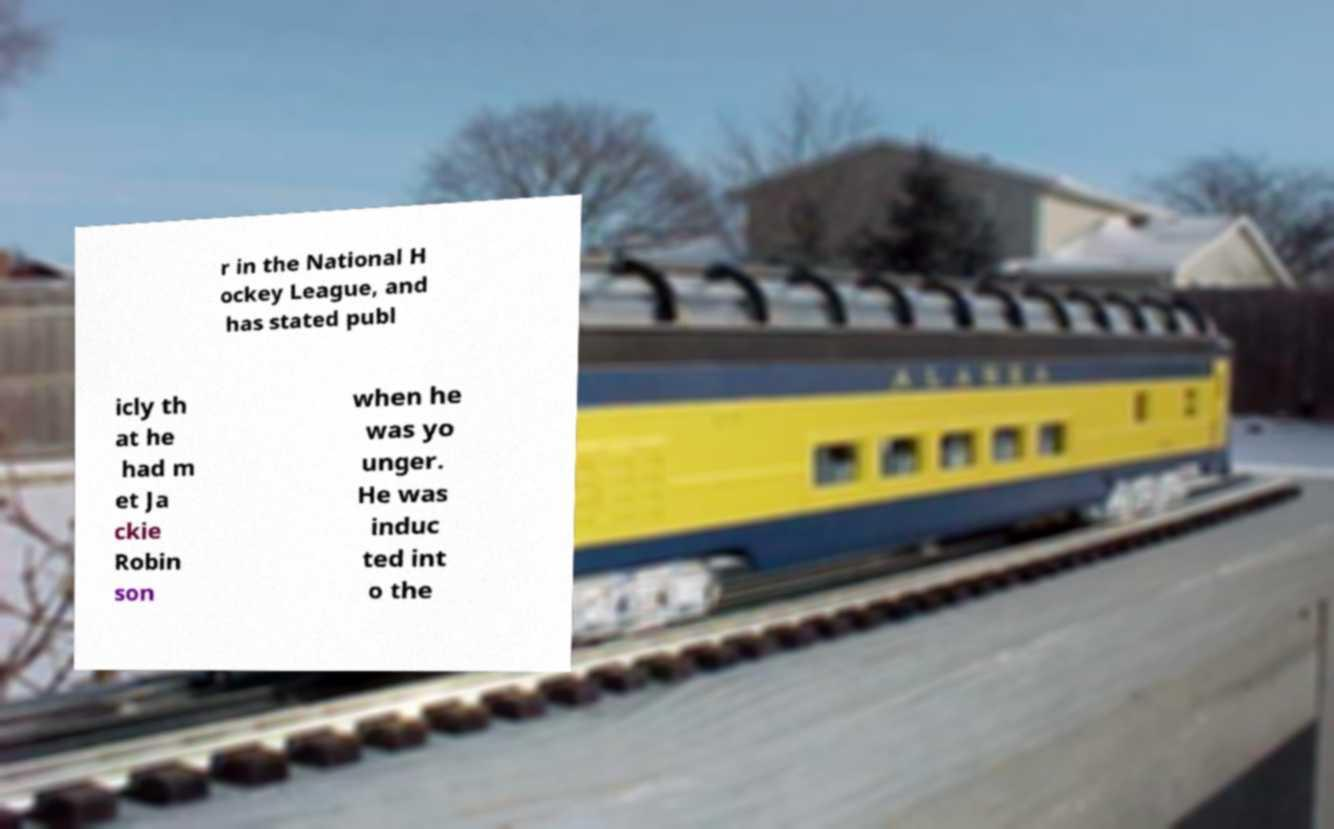Please identify and transcribe the text found in this image. r in the National H ockey League, and has stated publ icly th at he had m et Ja ckie Robin son when he was yo unger. He was induc ted int o the 